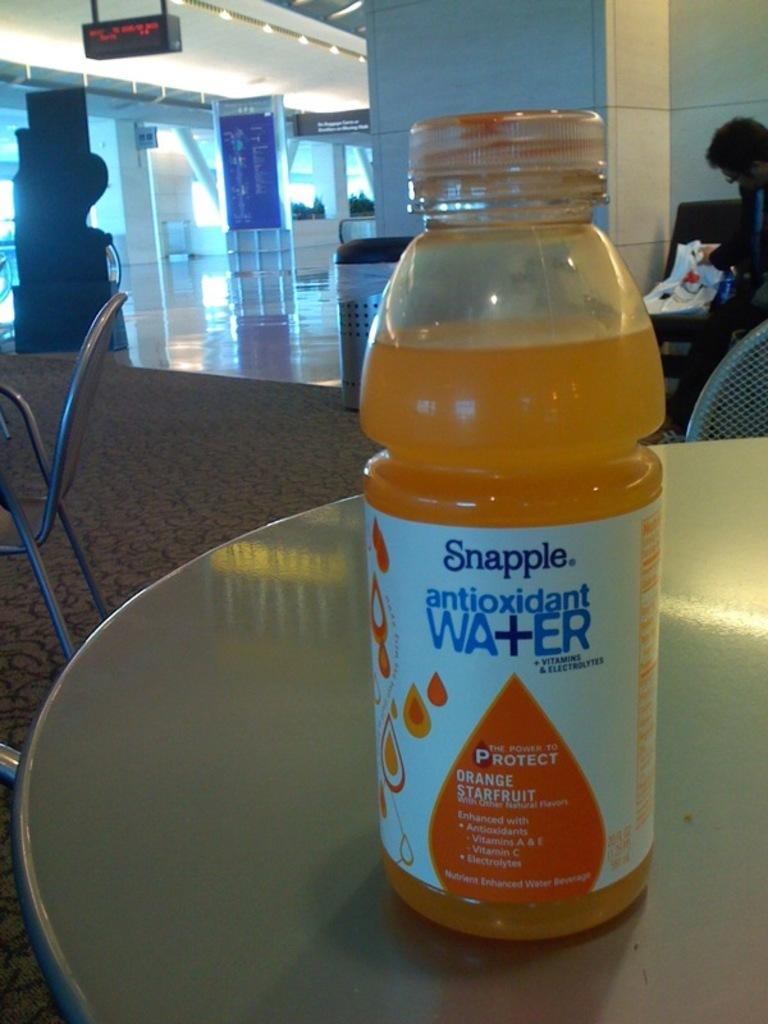Provide a one-sentence caption for the provided image. A bottle of Snapple antioxidant water in the flavor Orange Starfruit. 